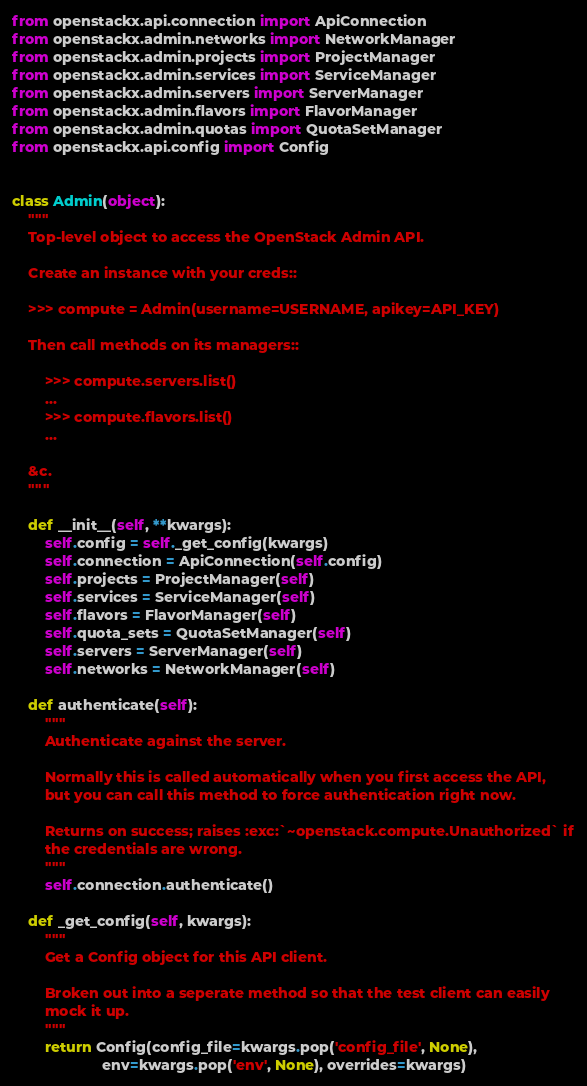<code> <loc_0><loc_0><loc_500><loc_500><_Python_>from openstackx.api.connection import ApiConnection
from openstackx.admin.networks import NetworkManager
from openstackx.admin.projects import ProjectManager
from openstackx.admin.services import ServiceManager
from openstackx.admin.servers import ServerManager
from openstackx.admin.flavors import FlavorManager
from openstackx.admin.quotas import QuotaSetManager
from openstackx.api.config import Config


class Admin(object):
    """
    Top-level object to access the OpenStack Admin API.

    Create an instance with your creds::

    >>> compute = Admin(username=USERNAME, apikey=API_KEY)

    Then call methods on its managers::

        >>> compute.servers.list()
        ...
        >>> compute.flavors.list()
        ...

    &c.
    """

    def __init__(self, **kwargs):
        self.config = self._get_config(kwargs)
        self.connection = ApiConnection(self.config)
        self.projects = ProjectManager(self)
        self.services = ServiceManager(self)
        self.flavors = FlavorManager(self)
        self.quota_sets = QuotaSetManager(self)
        self.servers = ServerManager(self)
        self.networks = NetworkManager(self)

    def authenticate(self):
        """
        Authenticate against the server.

        Normally this is called automatically when you first access the API,
        but you can call this method to force authentication right now.

        Returns on success; raises :exc:`~openstack.compute.Unauthorized` if
        the credentials are wrong.
        """
        self.connection.authenticate()

    def _get_config(self, kwargs):
        """
        Get a Config object for this API client.

        Broken out into a seperate method so that the test client can easily
        mock it up.
        """
        return Config(config_file=kwargs.pop('config_file', None),
                      env=kwargs.pop('env', None), overrides=kwargs)
</code> 